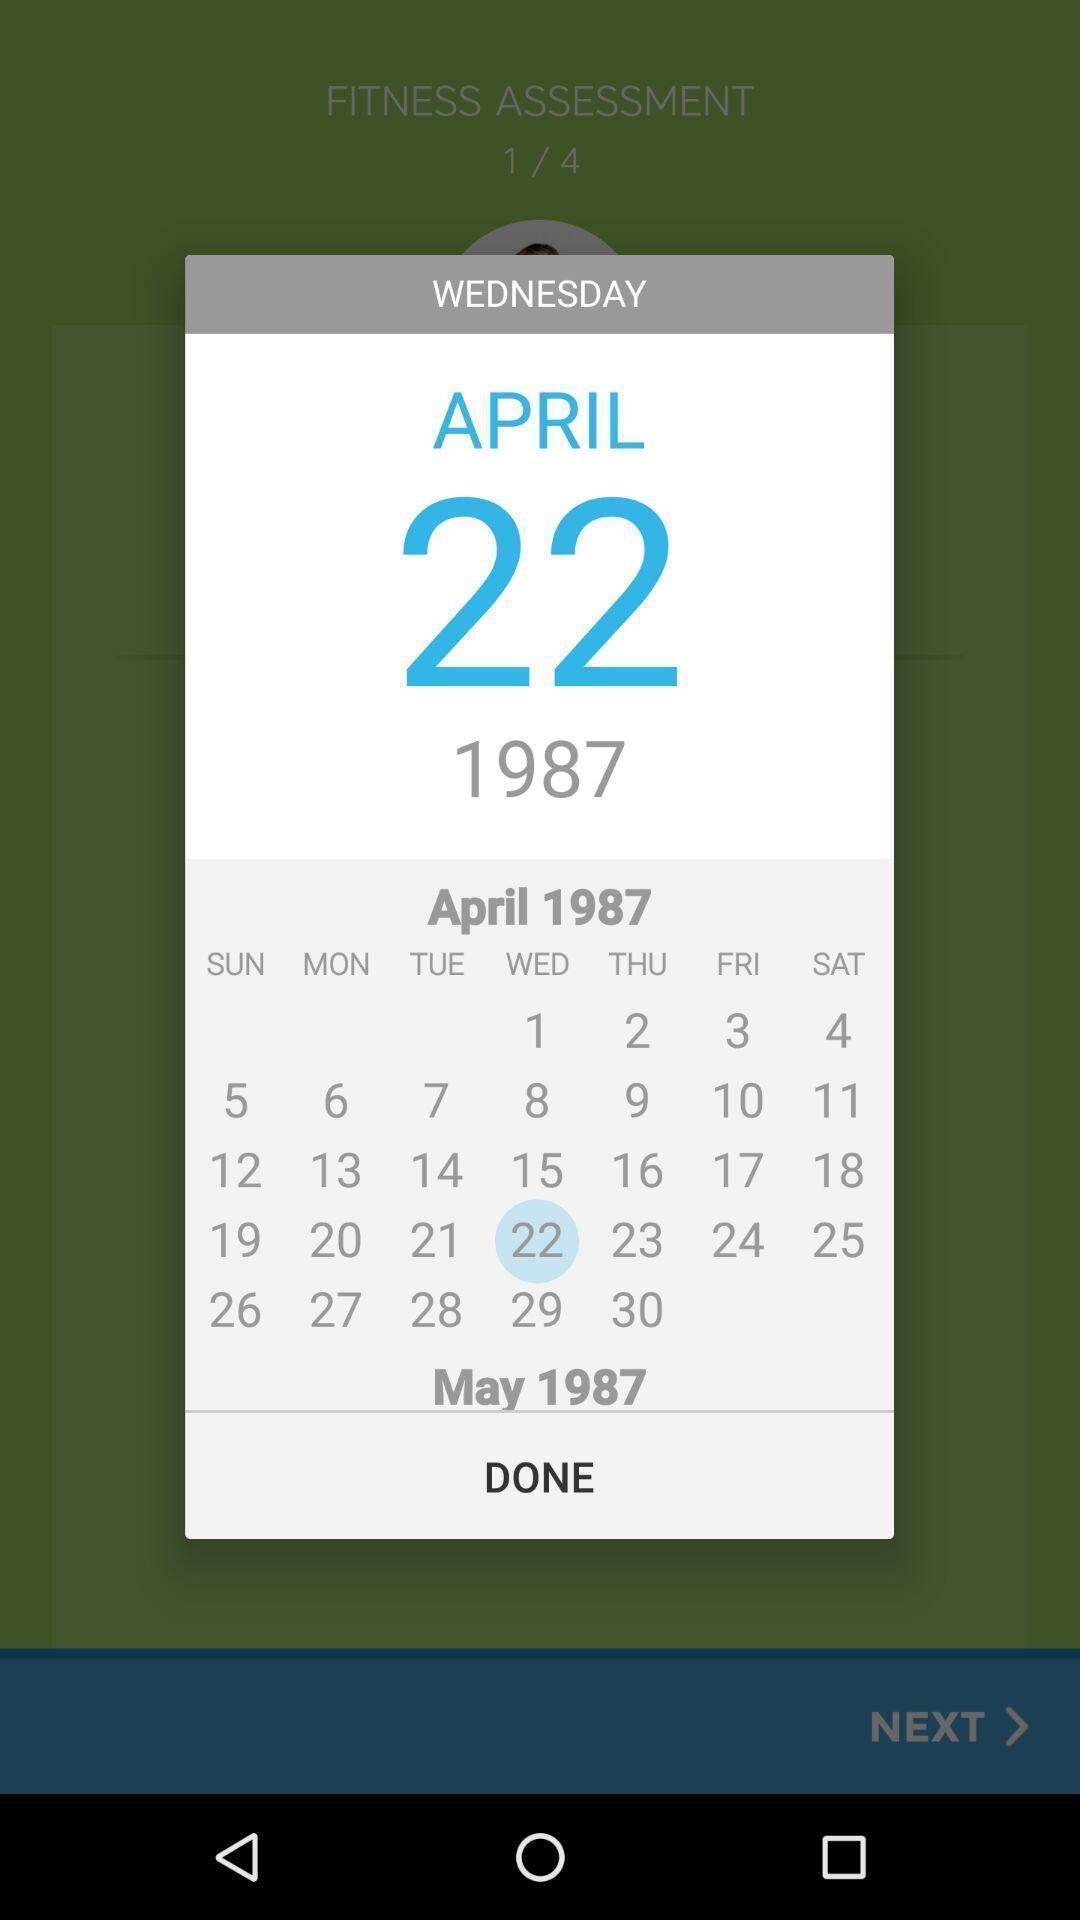Explain the elements present in this screenshot. Pop-up showing the calendar page. 